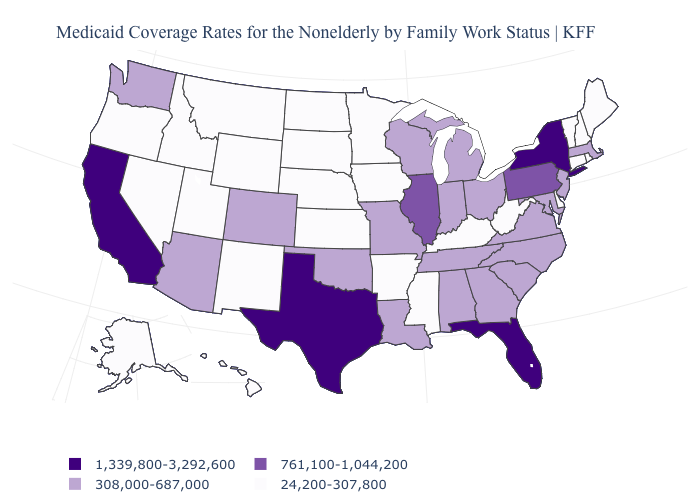What is the value of Hawaii?
Be succinct. 24,200-307,800. Is the legend a continuous bar?
Quick response, please. No. Among the states that border Montana , which have the highest value?
Answer briefly. Idaho, North Dakota, South Dakota, Wyoming. What is the highest value in the USA?
Write a very short answer. 1,339,800-3,292,600. What is the value of Illinois?
Quick response, please. 761,100-1,044,200. What is the value of Arkansas?
Quick response, please. 24,200-307,800. Among the states that border Virginia , does Tennessee have the lowest value?
Concise answer only. No. Does the map have missing data?
Write a very short answer. No. What is the highest value in the USA?
Write a very short answer. 1,339,800-3,292,600. Which states have the lowest value in the MidWest?
Short answer required. Iowa, Kansas, Minnesota, Nebraska, North Dakota, South Dakota. Does the first symbol in the legend represent the smallest category?
Keep it brief. No. What is the value of Wyoming?
Give a very brief answer. 24,200-307,800. What is the value of Connecticut?
Short answer required. 24,200-307,800. Which states have the lowest value in the Northeast?
Quick response, please. Connecticut, Maine, New Hampshire, Rhode Island, Vermont. Is the legend a continuous bar?
Keep it brief. No. 